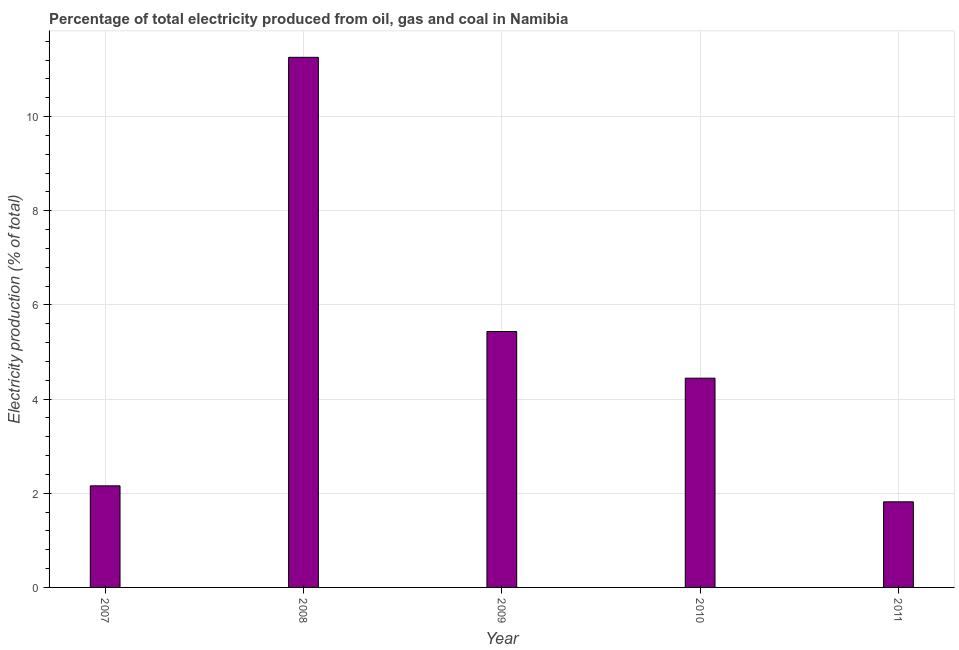Does the graph contain grids?
Offer a very short reply. Yes. What is the title of the graph?
Provide a succinct answer. Percentage of total electricity produced from oil, gas and coal in Namibia. What is the label or title of the X-axis?
Give a very brief answer. Year. What is the label or title of the Y-axis?
Offer a very short reply. Electricity production (% of total). What is the electricity production in 2011?
Offer a very short reply. 1.82. Across all years, what is the maximum electricity production?
Your response must be concise. 11.26. Across all years, what is the minimum electricity production?
Offer a terse response. 1.82. What is the sum of the electricity production?
Provide a short and direct response. 25.12. What is the difference between the electricity production in 2009 and 2011?
Make the answer very short. 3.62. What is the average electricity production per year?
Provide a succinct answer. 5.02. What is the median electricity production?
Provide a short and direct response. 4.44. Do a majority of the years between 2008 and 2011 (inclusive) have electricity production greater than 2 %?
Keep it short and to the point. Yes. What is the ratio of the electricity production in 2008 to that in 2009?
Your answer should be very brief. 2.07. What is the difference between the highest and the second highest electricity production?
Offer a very short reply. 5.82. Is the sum of the electricity production in 2009 and 2010 greater than the maximum electricity production across all years?
Your response must be concise. No. What is the difference between the highest and the lowest electricity production?
Your answer should be very brief. 9.44. In how many years, is the electricity production greater than the average electricity production taken over all years?
Your answer should be very brief. 2. How many bars are there?
Offer a very short reply. 5. Are the values on the major ticks of Y-axis written in scientific E-notation?
Keep it short and to the point. No. What is the Electricity production (% of total) in 2007?
Your answer should be very brief. 2.16. What is the Electricity production (% of total) of 2008?
Provide a short and direct response. 11.26. What is the Electricity production (% of total) in 2009?
Offer a terse response. 5.44. What is the Electricity production (% of total) in 2010?
Your response must be concise. 4.44. What is the Electricity production (% of total) in 2011?
Ensure brevity in your answer.  1.82. What is the difference between the Electricity production (% of total) in 2007 and 2008?
Keep it short and to the point. -9.1. What is the difference between the Electricity production (% of total) in 2007 and 2009?
Ensure brevity in your answer.  -3.28. What is the difference between the Electricity production (% of total) in 2007 and 2010?
Offer a terse response. -2.29. What is the difference between the Electricity production (% of total) in 2007 and 2011?
Make the answer very short. 0.34. What is the difference between the Electricity production (% of total) in 2008 and 2009?
Ensure brevity in your answer.  5.82. What is the difference between the Electricity production (% of total) in 2008 and 2010?
Provide a succinct answer. 6.82. What is the difference between the Electricity production (% of total) in 2008 and 2011?
Give a very brief answer. 9.44. What is the difference between the Electricity production (% of total) in 2009 and 2011?
Make the answer very short. 3.62. What is the difference between the Electricity production (% of total) in 2010 and 2011?
Provide a short and direct response. 2.63. What is the ratio of the Electricity production (% of total) in 2007 to that in 2008?
Provide a short and direct response. 0.19. What is the ratio of the Electricity production (% of total) in 2007 to that in 2009?
Keep it short and to the point. 0.4. What is the ratio of the Electricity production (% of total) in 2007 to that in 2010?
Make the answer very short. 0.48. What is the ratio of the Electricity production (% of total) in 2007 to that in 2011?
Make the answer very short. 1.19. What is the ratio of the Electricity production (% of total) in 2008 to that in 2009?
Provide a short and direct response. 2.07. What is the ratio of the Electricity production (% of total) in 2008 to that in 2010?
Provide a short and direct response. 2.53. What is the ratio of the Electricity production (% of total) in 2008 to that in 2011?
Give a very brief answer. 6.19. What is the ratio of the Electricity production (% of total) in 2009 to that in 2010?
Give a very brief answer. 1.22. What is the ratio of the Electricity production (% of total) in 2009 to that in 2011?
Keep it short and to the point. 2.99. What is the ratio of the Electricity production (% of total) in 2010 to that in 2011?
Provide a succinct answer. 2.44. 